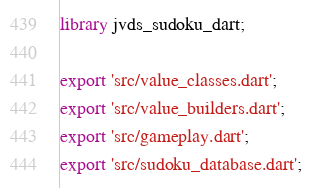Convert code to text. <code><loc_0><loc_0><loc_500><loc_500><_Dart_>library jvds_sudoku_dart;

export 'src/value_classes.dart';
export 'src/value_builders.dart';
export 'src/gameplay.dart';
export 'src/sudoku_database.dart';</code> 